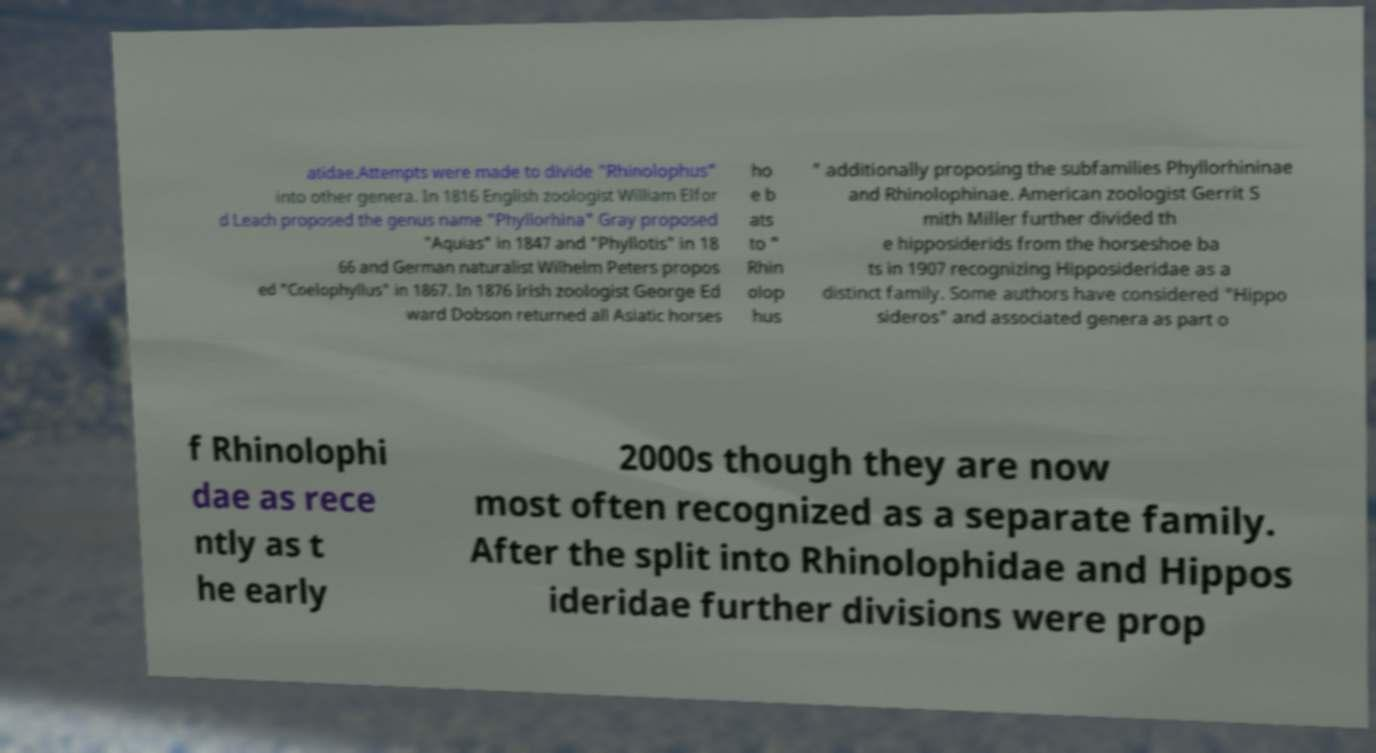Can you accurately transcribe the text from the provided image for me? atidae.Attempts were made to divide "Rhinolophus" into other genera. In 1816 English zoologist William Elfor d Leach proposed the genus name "Phyllorhina" Gray proposed "Aquias" in 1847 and "Phyllotis" in 18 66 and German naturalist Wilhelm Peters propos ed "Coelophyllus" in 1867. In 1876 Irish zoologist George Ed ward Dobson returned all Asiatic horses ho e b ats to " Rhin olop hus " additionally proposing the subfamilies Phyllorhininae and Rhinolophinae. American zoologist Gerrit S mith Miller further divided th e hipposiderids from the horseshoe ba ts in 1907 recognizing Hipposideridae as a distinct family. Some authors have considered "Hippo sideros" and associated genera as part o f Rhinolophi dae as rece ntly as t he early 2000s though they are now most often recognized as a separate family. After the split into Rhinolophidae and Hippos ideridae further divisions were prop 